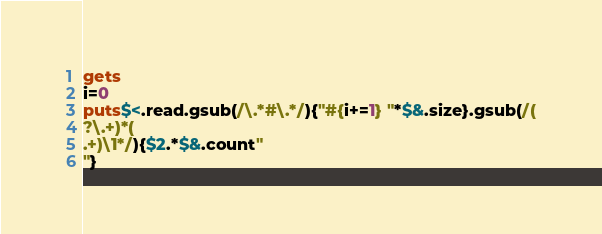Convert code to text. <code><loc_0><loc_0><loc_500><loc_500><_Ruby_>gets
i=0
puts$<.read.gsub(/\.*#\.*/){"#{i+=1} "*$&.size}.gsub(/(
?\.+)*(
.+)\1*/){$2.*$&.count"
"}</code> 